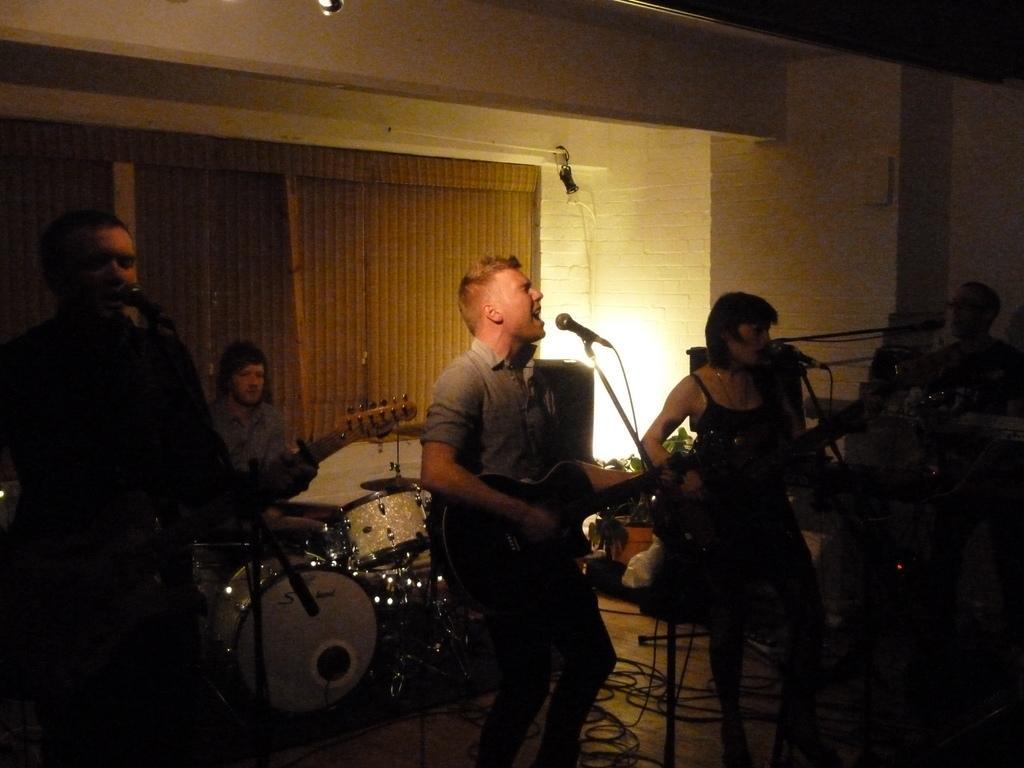How would you summarize this image in a sentence or two? In this picture I can see 4 men and a woman and I see that 4 of them are standing in front holding musical instruments in their hands and in the background I can see a man who is sitting near to the drums and on the floor I can see the wires. In the center of this picture I can see the light and I see that this picture is a bit in dark. 